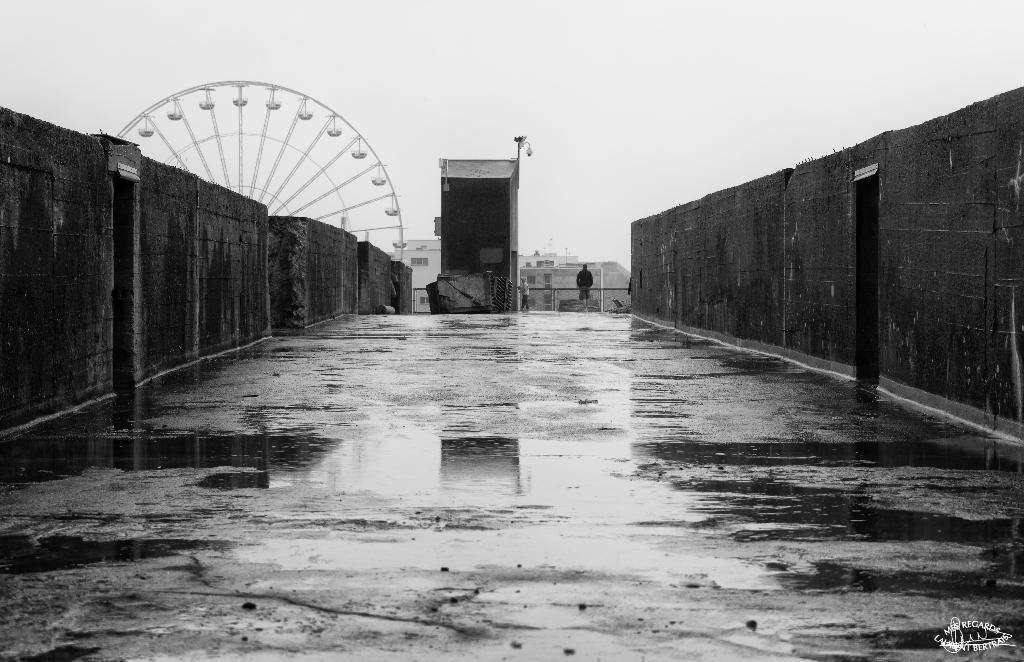Could you give a brief overview of what you see in this image? An outdoor picture. This is giant wheel. Far there are many buildings. The man is standing here. 